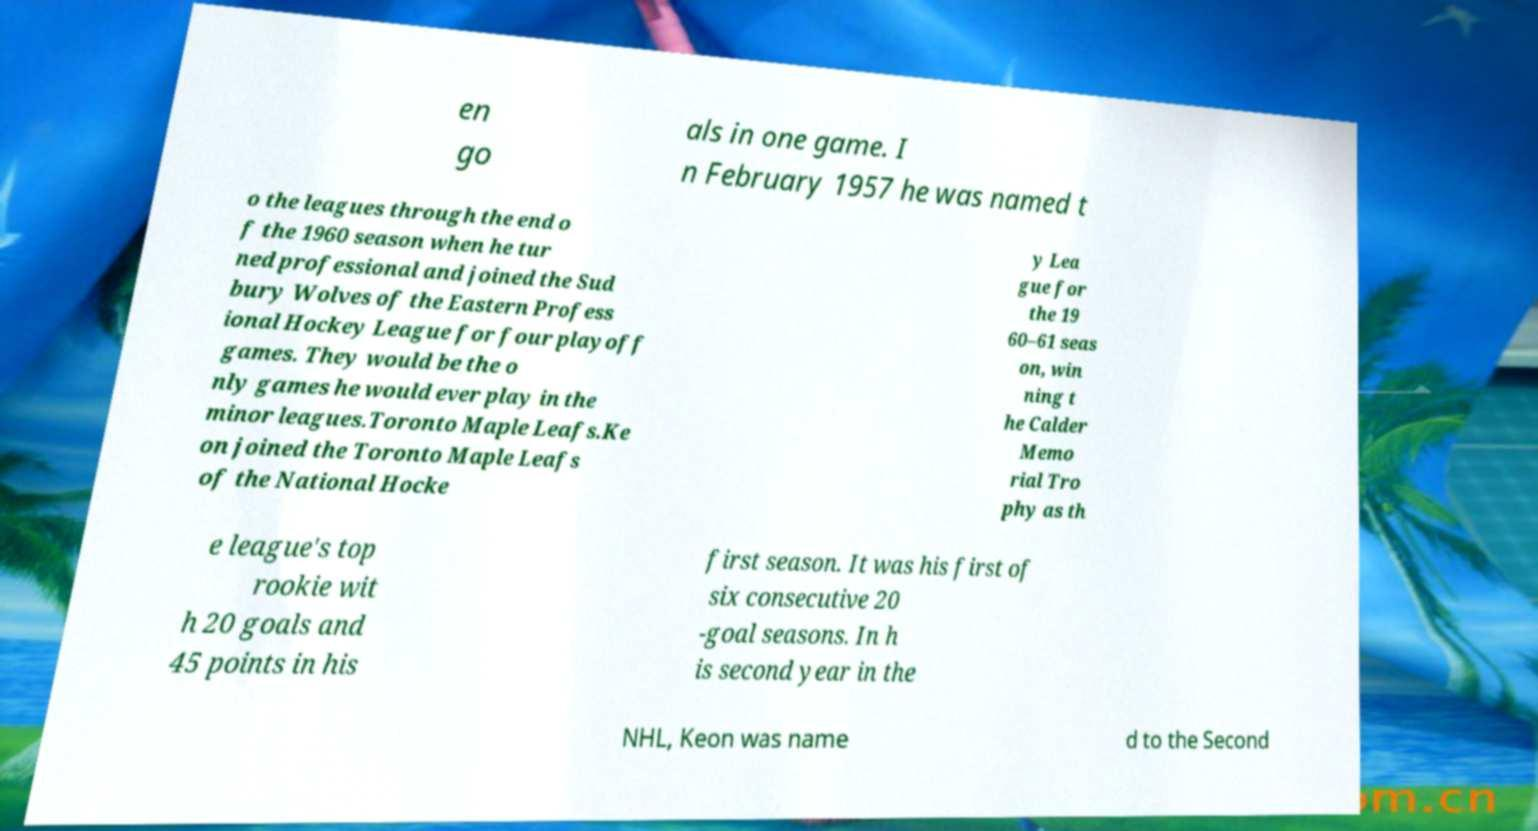Could you assist in decoding the text presented in this image and type it out clearly? en go als in one game. I n February 1957 he was named t o the leagues through the end o f the 1960 season when he tur ned professional and joined the Sud bury Wolves of the Eastern Profess ional Hockey League for four playoff games. They would be the o nly games he would ever play in the minor leagues.Toronto Maple Leafs.Ke on joined the Toronto Maple Leafs of the National Hocke y Lea gue for the 19 60–61 seas on, win ning t he Calder Memo rial Tro phy as th e league's top rookie wit h 20 goals and 45 points in his first season. It was his first of six consecutive 20 -goal seasons. In h is second year in the NHL, Keon was name d to the Second 